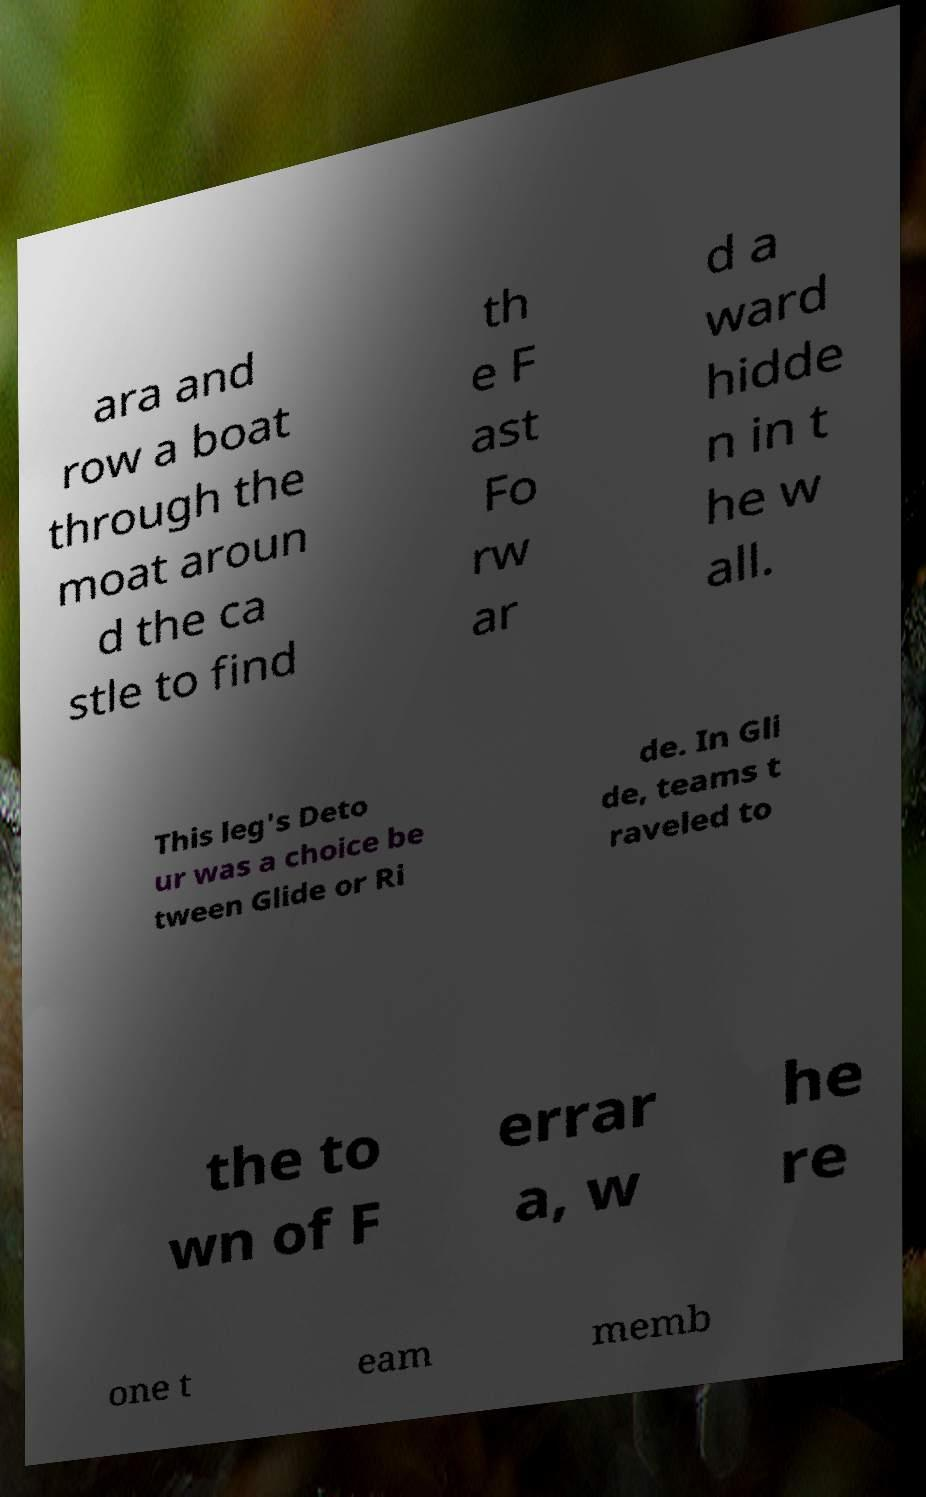There's text embedded in this image that I need extracted. Can you transcribe it verbatim? ara and row a boat through the moat aroun d the ca stle to find th e F ast Fo rw ar d a ward hidde n in t he w all. This leg's Deto ur was a choice be tween Glide or Ri de. In Gli de, teams t raveled to the to wn of F errar a, w he re one t eam memb 